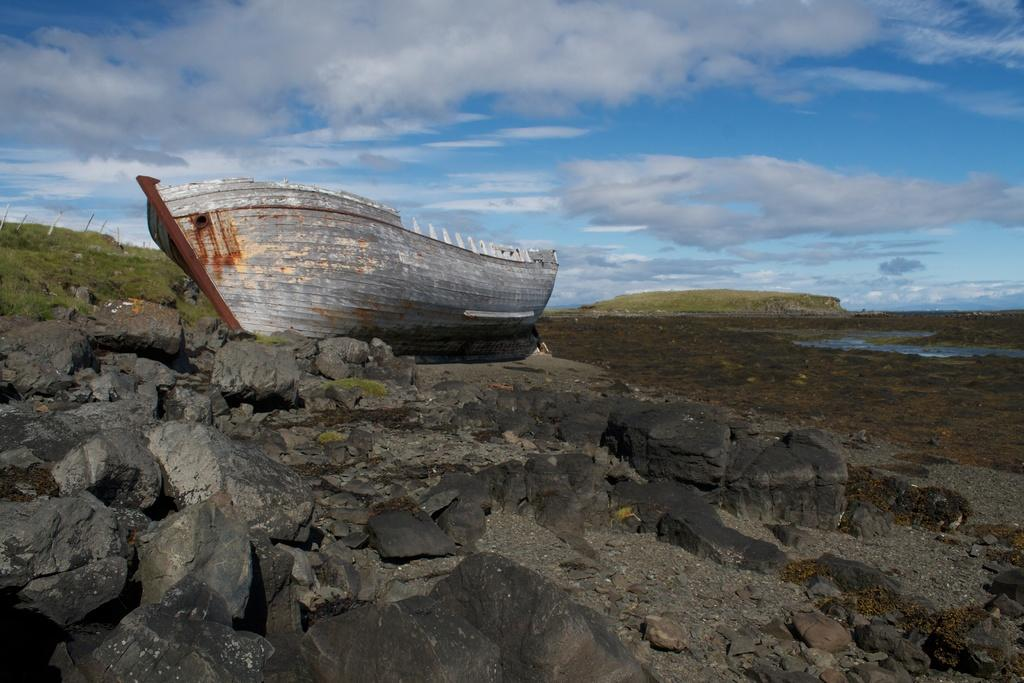What is located on the left side of the image? There is a boat on the left side of the image. What can be seen at the bottom of the image? There are rocks at the bottom of the image. What is visible in the background of the image? There is a hill and the sky visible in the background of the image. Can you see any ants carrying a needle in the image? There are no ants or needles present in the image. What type of connection is established between the boat and the hill in the image? There is no connection established between the boat and the hill in the image; they are separate elements in the scene. 